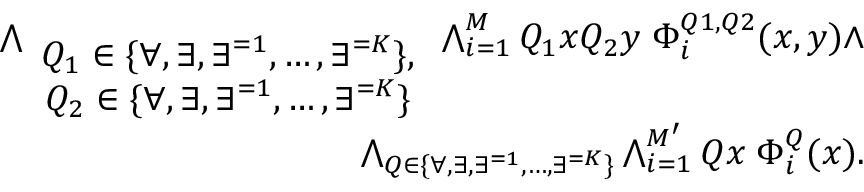Convert formula to latex. <formula><loc_0><loc_0><loc_500><loc_500>\begin{array} { r } { \bigwedge _ { \begin{array} { c } { Q _ { 1 } \in \{ \forall , \exists , \exists ^ { = 1 } , \dots , \exists ^ { = K } \} , } \\ { Q _ { 2 } \in \{ \forall , \exists , \exists ^ { = 1 } , \dots , \exists ^ { = K } \} } \end{array} } \bigwedge _ { i = 1 } ^ { M } Q _ { 1 } x Q _ { 2 } y \, \Phi _ { i } ^ { Q 1 , Q 2 } ( x , y ) \wedge } \\ { \bigwedge _ { Q \in \{ \forall , \exists , \exists ^ { = 1 } , \dots , \exists ^ { = K } \} } \bigwedge _ { i = 1 } ^ { M ^ { \prime } } Q x \, \Phi _ { i } ^ { Q } ( x ) . } \end{array}</formula> 